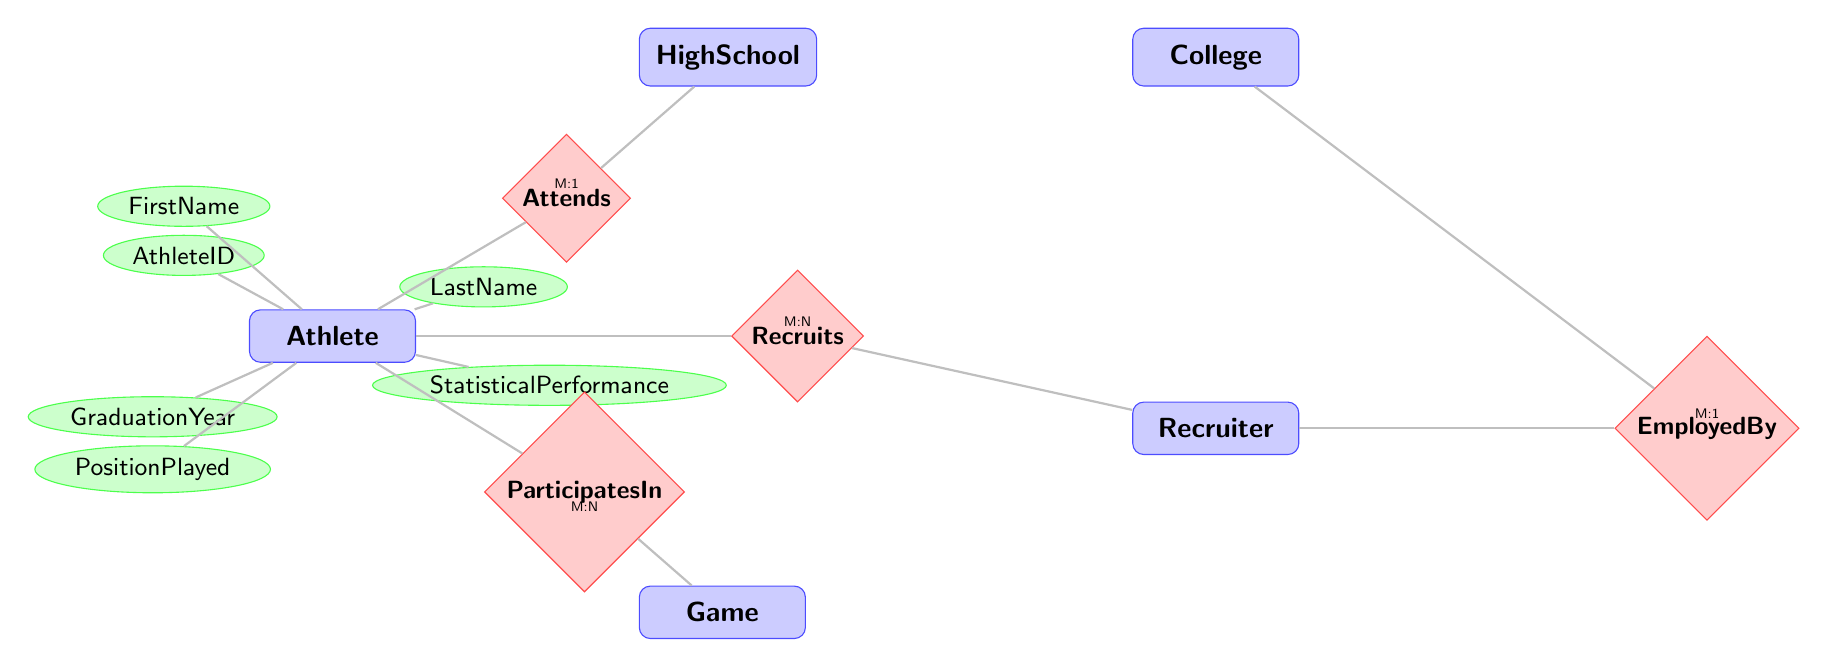What are the possible relationships an Athlete can have in this diagram? The diagram shows that an Athlete can attend a High School, participate in Games, and be recruited by Recruiters. This can be inferred from examining the relationships associated with the Athlete node: Attends, ParticipatesIn, and Recruits.
Answer: Attends, ParticipatesIn, Recruits How many attributes are associated with the Athlete entity? By examining the Athlete entity, we can see that it has six attributes: AthleteID, FirstName, LastName, GraduationYear, PositionPlayed, and StatisticalPerformance. The count of these attributes gives us the answer.
Answer: 6 Which entity is employed by the Recruiter entity? The relationship EmployedBy indicates that Recruiters are employed by Colleges. By locating the EmployedBy relationship, we can see that it connects the Recruiter entity to the College entity.
Answer: College How many entities are involved in the relationship 'ParticipatesIn'? The 'ParticipatesIn' relationship connects the Athlete entity to the Game entity. Each relationship is depicted between two specific entities, which can be counted directly from the diagram.
Answer: 2 Does one Athlete play in multiple Games? The relationship 'ParticipatesIn' has a Many-to-Many (M:N) multiplicity. This indicates that each Athlete can participate in multiple Games, and likewise, each Game can have multiple Athletes participating. This understanding is based on the multiplicity notation next to the ParticipatesIn relationship.
Answer: Yes What is the multiplicity of the relationship between Recruiter and Athlete? The diagram shows that the relationship Recruits between Recruiter and Athlete has a Many-to-Many (M:N) multiplicity, which can be confirmed through the notation included next to the Recruits relationship.
Answer: M:N Which entity has the attributes Location and SchoolName? From the available entities, we can see that the HighSchool entity has the attributes Location and SchoolName. By examining the attributes listed for the HighSchool entity, we can identify these specific attributes.
Answer: HighSchool What type of diagram is being displayed? The diagram is an Entity Relationship Diagram (ERD), which is designed to model the relationships between different entities in a system. This can be concluded from the nature of the entities and relationships depicted.
Answer: Entity Relationship Diagram 